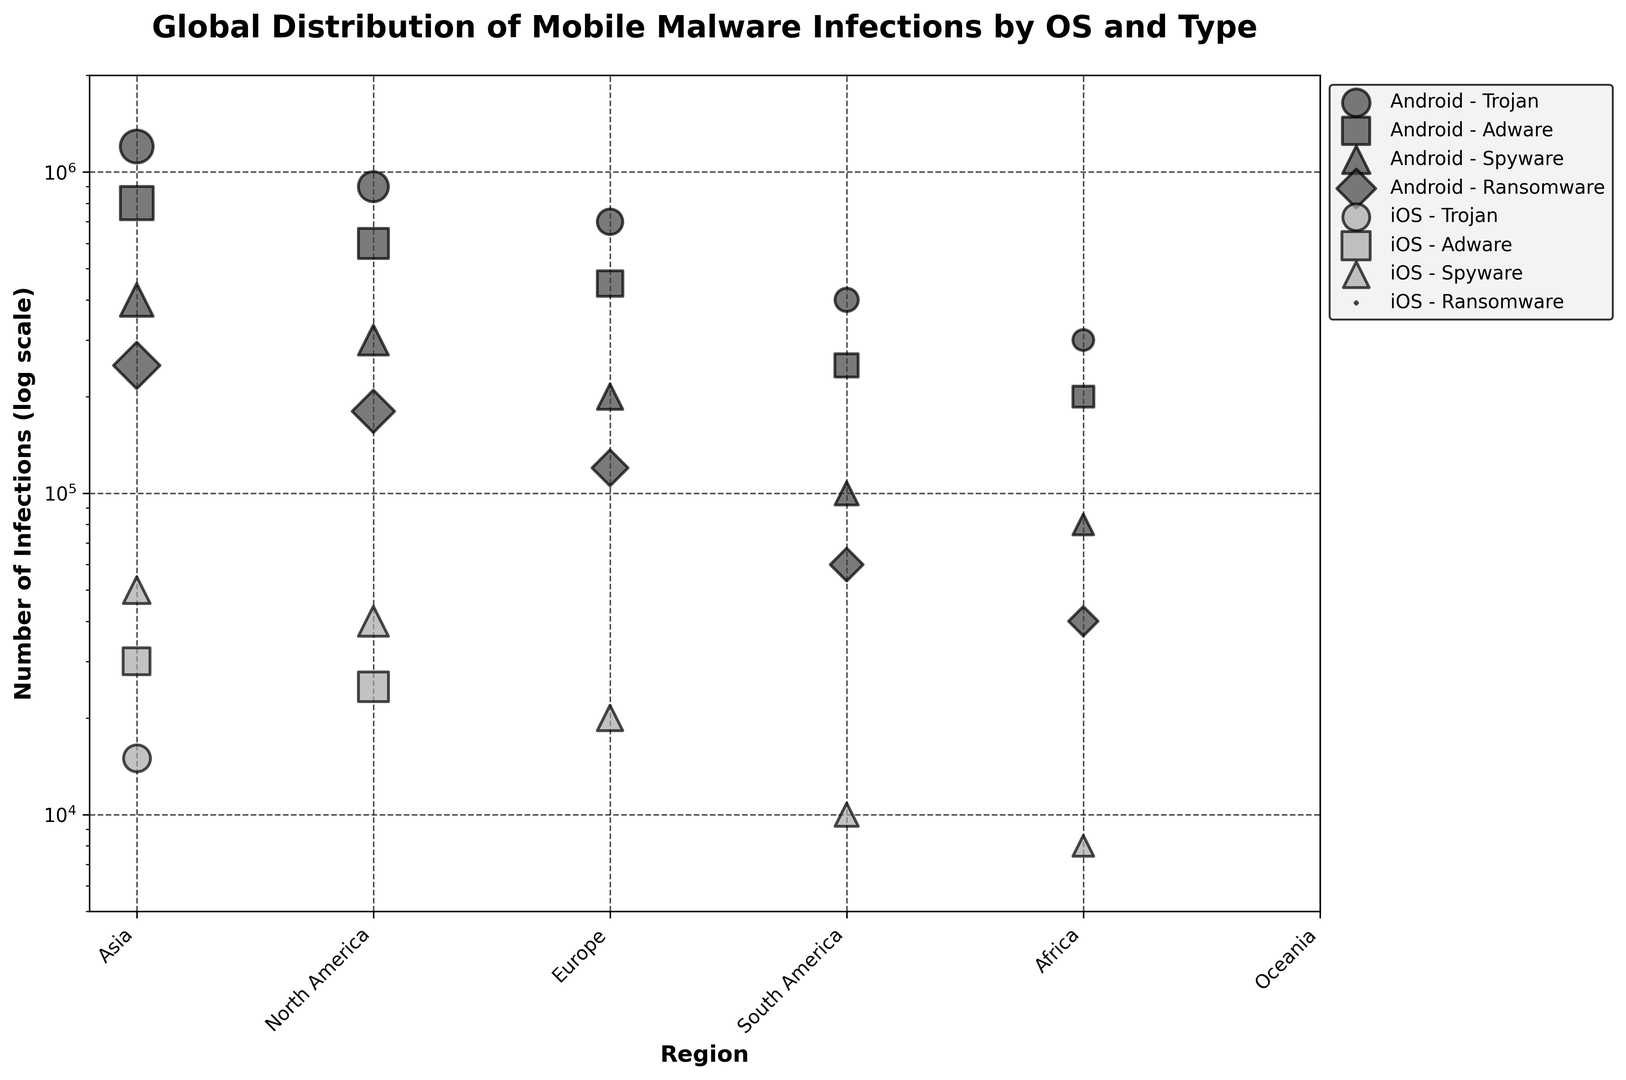What's the highest number of infections for any malware type on Android in Asia? Look at the bubble for Android in Asia and identify the malware type with the largest circle. The 'Trojan' malware has the largest circle, representing 1,200,000 infections.
Answer: 1,200,000 Which region has the highest number of iOS spyware infections? Compare the size of the circles for iOS spyware infections across all regions. North America has the largest circle for iOS spyware infections, with 50,000 infections.
Answer: North America What is the total number of Android ransomware infections in Europe and Asia? Sum the infections for Android ransomware in Europe and Asia. Europe: 180,000 and Asia: 250,000. Total = 180,000 + 250,000 = 430,000.
Answer: 430,000 Which region has the least variation in the number of Android infections across different malware types? Compare the range of circle sizes for Android infections across different malware types in each region. Oceania has the least variation, with the range being from 40,000 to 300,000.
Answer: Oceania For iOS, how do the infections of spyware compare to the total infections of adware and Trojan in North America? Add the iOS infections for adware (30,000) and Trojan (15,000) in North America, which equals 45,000. Compare this with the spyware infections, which are 50,000. Spyware infections are higher.
Answer: Higher Across all regions, which malware type has the largest total number of infections on Android? Sum the infections for each malware type on Android across all regions. Trojan has the largest total sum after summing up infections from all regions.
Answer: Trojan What are the total iOS spyware infections across all regions? Sum the iOS spyware infections from all regions: North America (50,000), Europe (40,000), South America (20,000), Africa (10,000), Oceania (8,000). Total = 50,000 + 40,000 + 20,000 + 10,000 + 8,000 = 128,000.
Answer: 128,000 In which region are Android adware infections closest in number to Android Trojan infections? Look at regions where the size of Android adware bubbles is closest to Trojan bubbles. In Oceania, Android adware (200,000) is relatively close to Android Trojan (300,000) compared to other regions.
Answer: Oceania What is the average number of infections for iOS spyware across Africa, South America, and Oceania? Add the infections for iOS spyware in Africa (10,000), South America (20,000), and Oceania (8,000), then divide by 3. (10,000 + 20,000 + 8,000) / 3 = 12,666.67 (rounded to two decimal places).
Answer: 12,666.67 